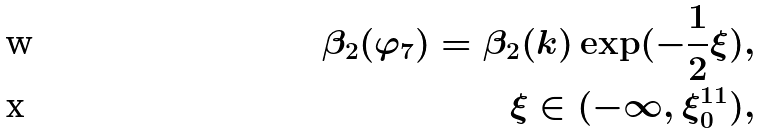<formula> <loc_0><loc_0><loc_500><loc_500>\beta _ { 2 } ( \varphi _ { 7 } ) = \beta _ { 2 } ( k ) \exp ( - \frac { 1 } { 2 } \xi ) , \\ \quad \xi \in ( - \infty , \xi _ { 0 } ^ { 1 1 } ) ,</formula> 